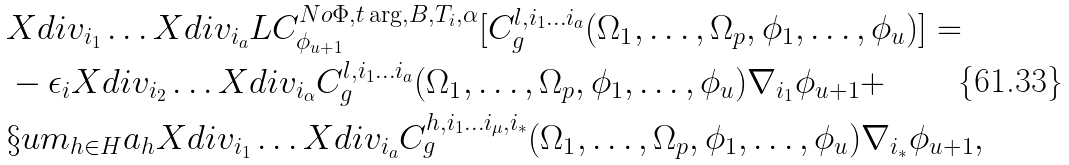<formula> <loc_0><loc_0><loc_500><loc_500>& X d i v _ { i _ { 1 } } \dots X d i v _ { i _ { a } } L C ^ { N o \Phi , t \arg , B , T _ { i } , \alpha } _ { \phi _ { u + 1 } } [ C ^ { l , i _ { 1 } \dots i _ { a } } _ { g } ( \Omega _ { 1 } , \dots , \Omega _ { p } , \phi _ { 1 } , \dots , \phi _ { u } ) ] = \\ & - \epsilon _ { i } X d i v _ { i _ { 2 } } \dots X d i v _ { i _ { \alpha } } C ^ { l , i _ { 1 } \dots i _ { a } } _ { g } ( \Omega _ { 1 } , \dots , \Omega _ { p } , \phi _ { 1 } , \dots , \phi _ { u } ) \nabla _ { i _ { 1 } } \phi _ { u + 1 } + \\ & \S u m _ { h \in H } a _ { h } X d i v _ { i _ { 1 } } \dots X d i v _ { i _ { a } } C ^ { h , i _ { 1 } \dots i _ { \mu } , i _ { * } } _ { g } ( \Omega _ { 1 } , \dots , \Omega _ { p } , \phi _ { 1 } , \dots , \phi _ { u } ) \nabla _ { i _ { * } } \phi _ { u + 1 } ,</formula> 